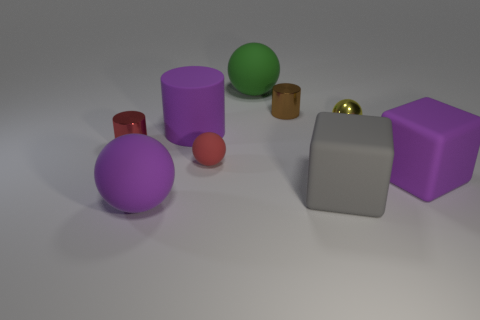Add 1 small green rubber balls. How many objects exist? 10 Subtract all matte balls. How many balls are left? 1 Subtract all balls. How many objects are left? 5 Subtract 0 cyan cylinders. How many objects are left? 9 Subtract all yellow cylinders. Subtract all green spheres. How many cylinders are left? 3 Subtract all metallic objects. Subtract all tiny red cylinders. How many objects are left? 5 Add 7 large purple rubber balls. How many large purple rubber balls are left? 8 Add 9 cyan cubes. How many cyan cubes exist? 9 